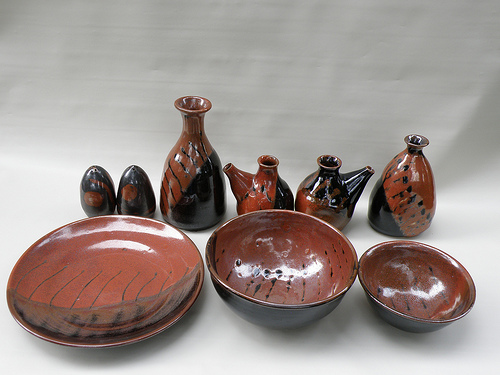Please provide a short description for this region: [0.73, 0.38, 0.88, 0.6]. In the region [0.73, 0.38, 0.88, 0.6], there is a brown and black vase. This vase combines traditional and modern aesthetics, making it a significant element of the collection. 